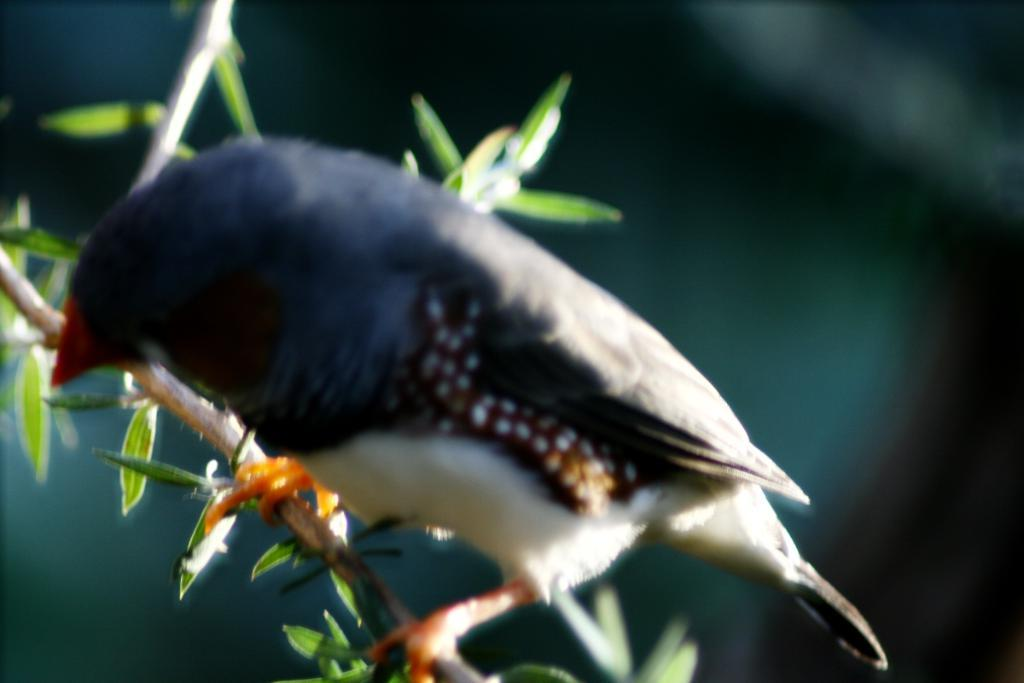What type of animal is in the image? There is a bird in the image. Where is the bird located? The bird is standing on a tree branch. Can you describe the background of the image? The background of the image is blurry. How many cows are visible in the image? There are no cows present in the image; it features a bird on a tree branch. What type of spy equipment can be seen in the image? There is no spy equipment present in the image. 